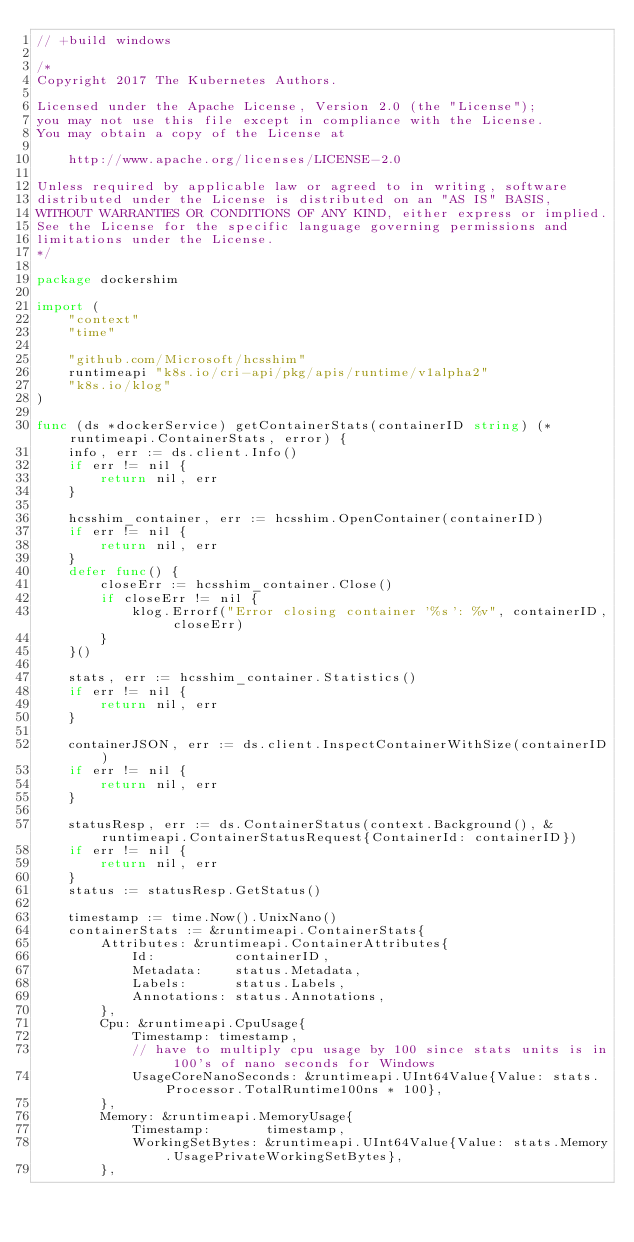<code> <loc_0><loc_0><loc_500><loc_500><_Go_>// +build windows

/*
Copyright 2017 The Kubernetes Authors.

Licensed under the Apache License, Version 2.0 (the "License");
you may not use this file except in compliance with the License.
You may obtain a copy of the License at

    http://www.apache.org/licenses/LICENSE-2.0

Unless required by applicable law or agreed to in writing, software
distributed under the License is distributed on an "AS IS" BASIS,
WITHOUT WARRANTIES OR CONDITIONS OF ANY KIND, either express or implied.
See the License for the specific language governing permissions and
limitations under the License.
*/

package dockershim

import (
	"context"
	"time"

	"github.com/Microsoft/hcsshim"
	runtimeapi "k8s.io/cri-api/pkg/apis/runtime/v1alpha2"
	"k8s.io/klog"
)

func (ds *dockerService) getContainerStats(containerID string) (*runtimeapi.ContainerStats, error) {
	info, err := ds.client.Info()
	if err != nil {
		return nil, err
	}

	hcsshim_container, err := hcsshim.OpenContainer(containerID)
	if err != nil {
		return nil, err
	}
	defer func() {
		closeErr := hcsshim_container.Close()
		if closeErr != nil {
			klog.Errorf("Error closing container '%s': %v", containerID, closeErr)
		}
	}()

	stats, err := hcsshim_container.Statistics()
	if err != nil {
		return nil, err
	}

	containerJSON, err := ds.client.InspectContainerWithSize(containerID)
	if err != nil {
		return nil, err
	}

	statusResp, err := ds.ContainerStatus(context.Background(), &runtimeapi.ContainerStatusRequest{ContainerId: containerID})
	if err != nil {
		return nil, err
	}
	status := statusResp.GetStatus()

	timestamp := time.Now().UnixNano()
	containerStats := &runtimeapi.ContainerStats{
		Attributes: &runtimeapi.ContainerAttributes{
			Id:          containerID,
			Metadata:    status.Metadata,
			Labels:      status.Labels,
			Annotations: status.Annotations,
		},
		Cpu: &runtimeapi.CpuUsage{
			Timestamp: timestamp,
			// have to multiply cpu usage by 100 since stats units is in 100's of nano seconds for Windows
			UsageCoreNanoSeconds: &runtimeapi.UInt64Value{Value: stats.Processor.TotalRuntime100ns * 100},
		},
		Memory: &runtimeapi.MemoryUsage{
			Timestamp:       timestamp,
			WorkingSetBytes: &runtimeapi.UInt64Value{Value: stats.Memory.UsagePrivateWorkingSetBytes},
		},</code> 